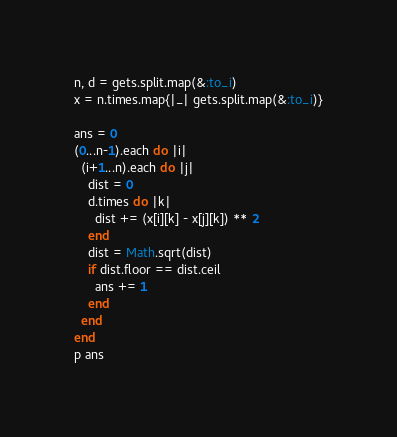Convert code to text. <code><loc_0><loc_0><loc_500><loc_500><_Ruby_>n, d = gets.split.map(&:to_i)
x = n.times.map{|_| gets.split.map(&:to_i)}

ans = 0
(0...n-1).each do |i|
  (i+1...n).each do |j|
    dist = 0
    d.times do |k|
      dist += (x[i][k] - x[j][k]) ** 2
    end
    dist = Math.sqrt(dist)
    if dist.floor == dist.ceil
      ans += 1
    end
  end
end
p ans</code> 